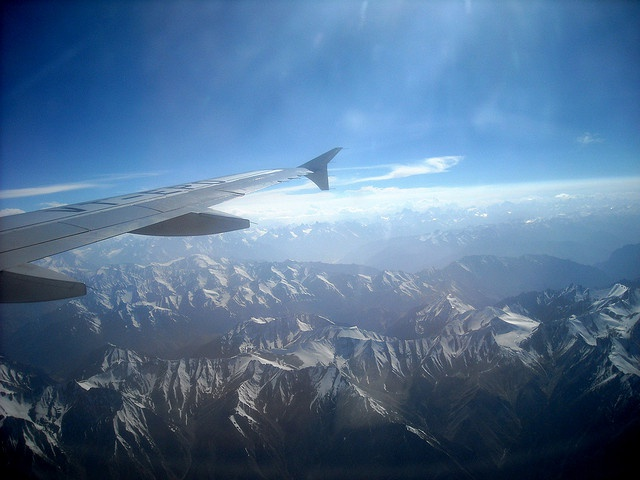Describe the objects in this image and their specific colors. I can see a airplane in black, gray, and darkgray tones in this image. 